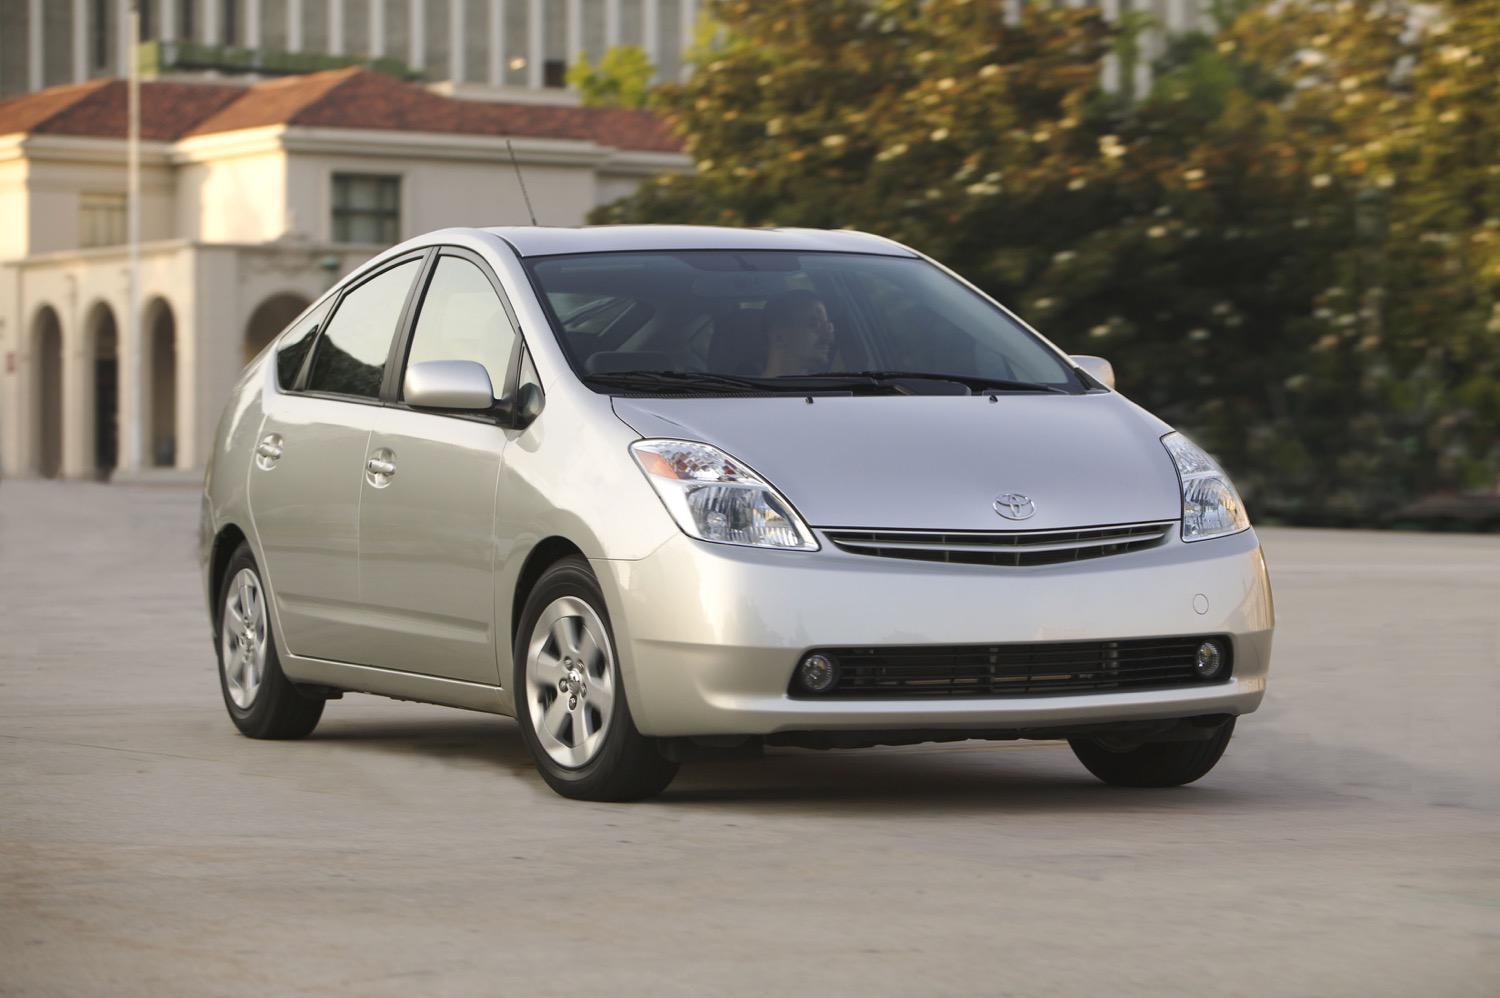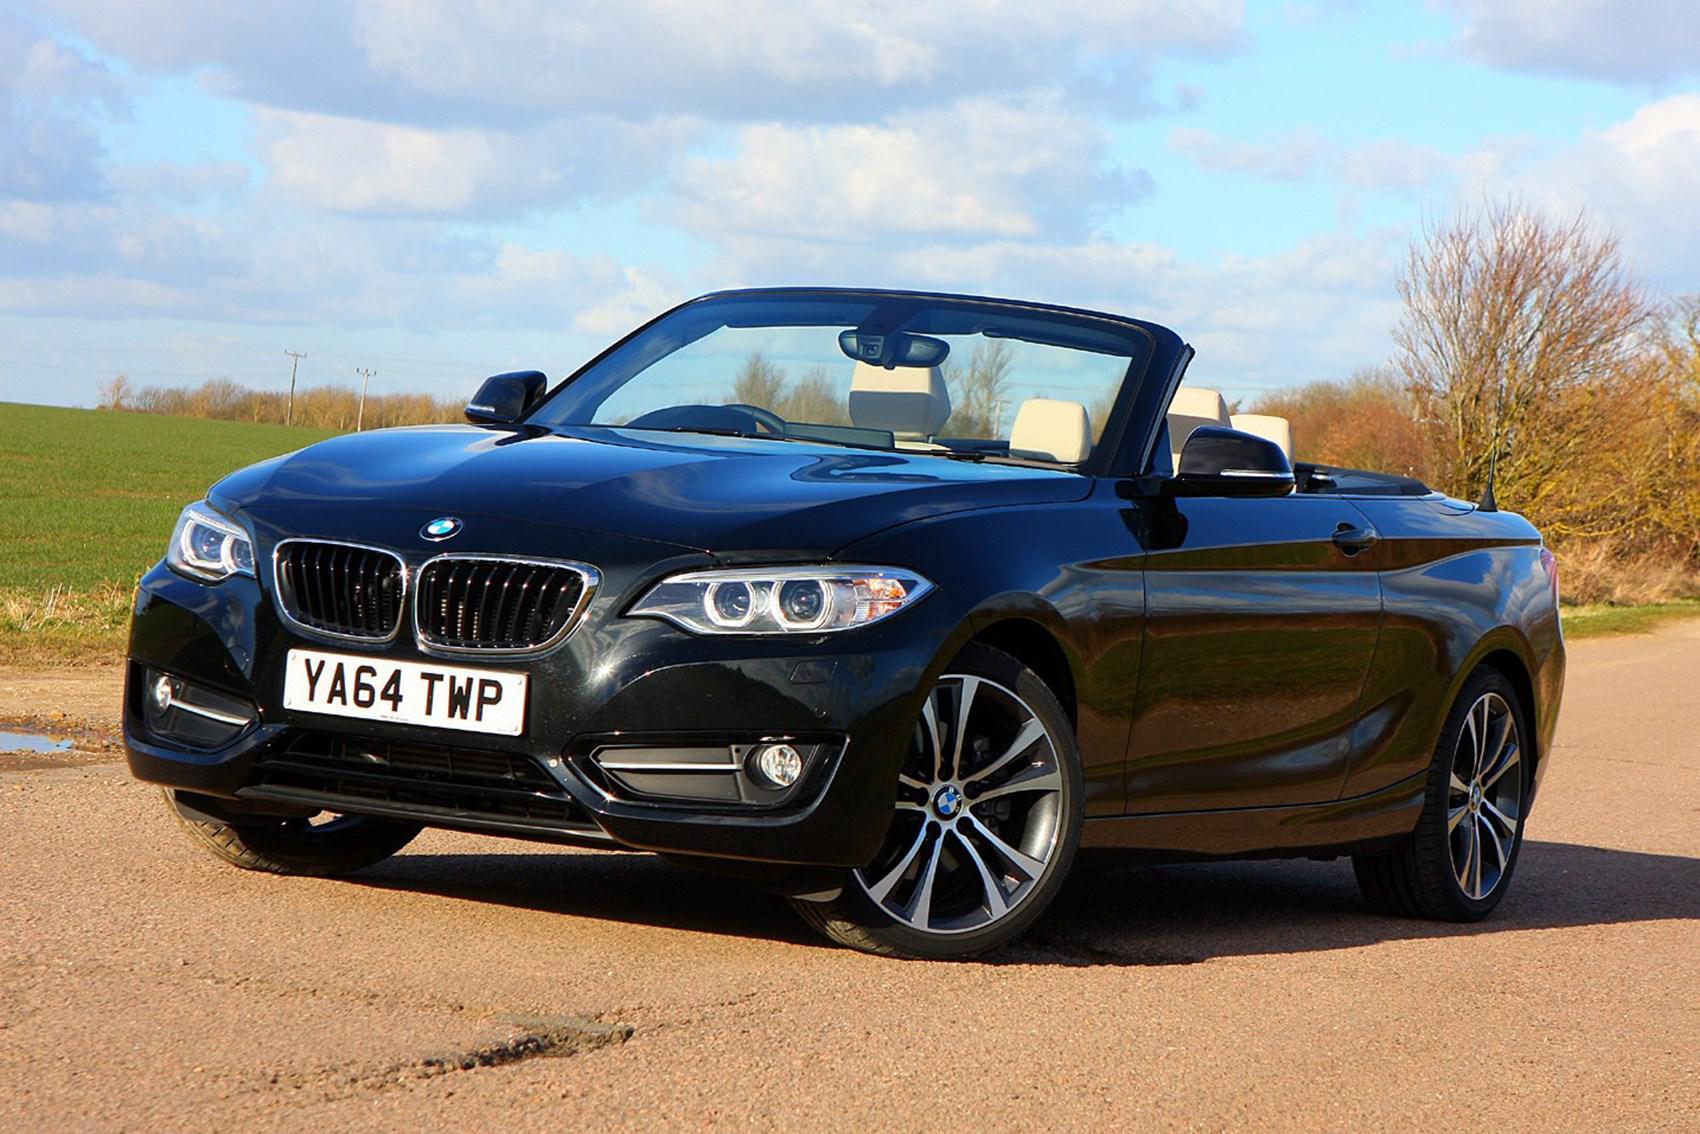The first image is the image on the left, the second image is the image on the right. Evaluate the accuracy of this statement regarding the images: "One of the images features a white convertible car.". Is it true? Answer yes or no. No. The first image is the image on the left, the second image is the image on the right. Given the left and right images, does the statement "One car has a hard top and the other car is a topless convertible, and the cars in the left and right images appear to face each other." hold true? Answer yes or no. Yes. 